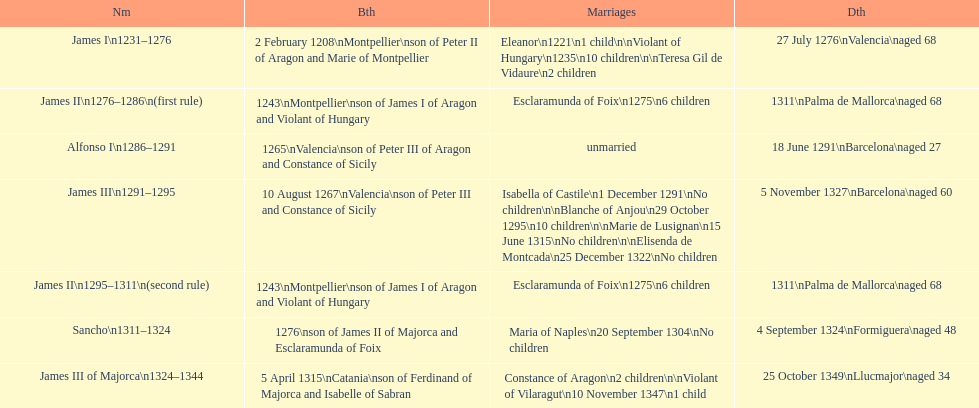What name is above james iii and below james ii? Alfonso I. 